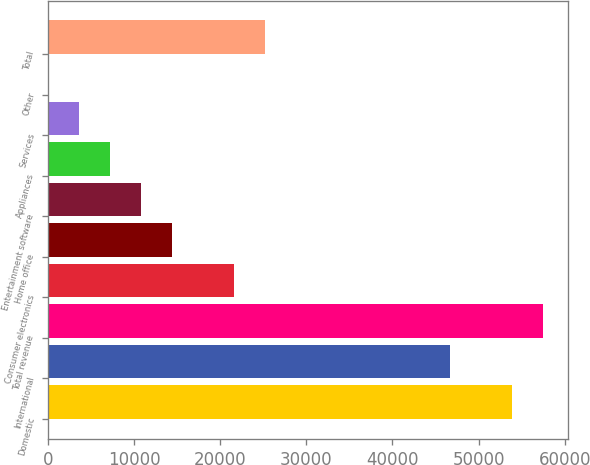Convert chart. <chart><loc_0><loc_0><loc_500><loc_500><bar_chart><fcel>Domestic<fcel>International<fcel>Total revenue<fcel>Consumer electronics<fcel>Home office<fcel>Entertainment software<fcel>Appliances<fcel>Services<fcel>Other<fcel>Total<nl><fcel>53900.5<fcel>46713.9<fcel>57493.8<fcel>21560.8<fcel>14374.2<fcel>10780.9<fcel>7187.6<fcel>3594.3<fcel>1<fcel>25154.1<nl></chart> 